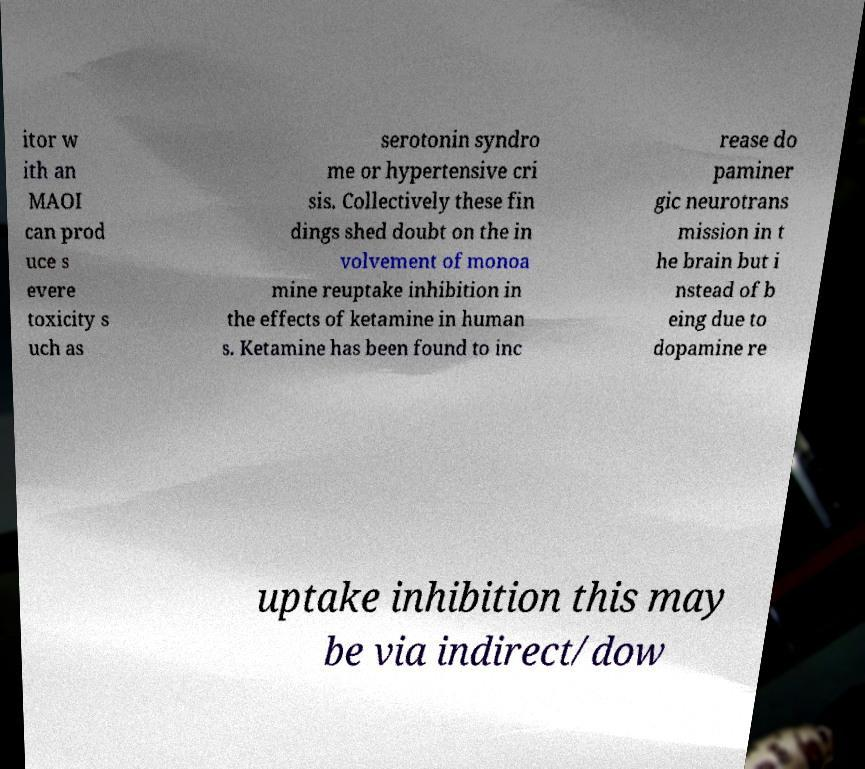Please identify and transcribe the text found in this image. itor w ith an MAOI can prod uce s evere toxicity s uch as serotonin syndro me or hypertensive cri sis. Collectively these fin dings shed doubt on the in volvement of monoa mine reuptake inhibition in the effects of ketamine in human s. Ketamine has been found to inc rease do paminer gic neurotrans mission in t he brain but i nstead of b eing due to dopamine re uptake inhibition this may be via indirect/dow 